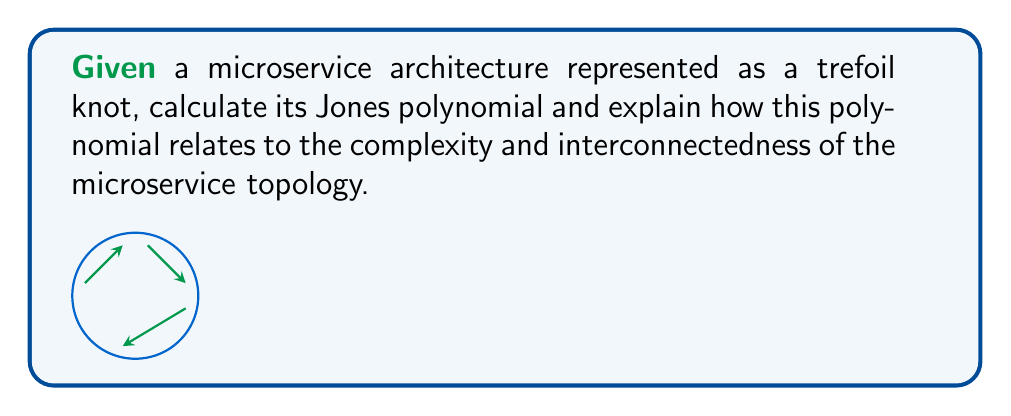Can you answer this question? To solve this problem, we'll follow these steps:

1. Identify the trefoil knot and its properties:
   The trefoil knot is the simplest non-trivial knot, with a crossing number of 3.

2. Calculate the Kauffman bracket polynomial:
   a. Assign variables A and B to the two types of smoothings at each crossing.
   b. Apply the skein relation: $\langle K \rangle = A\langle K_0 \rangle + A^{-1}\langle K_\infty \rangle$
   c. Simplify the resulting expression.

   $$\langle \text{Trefoil} \rangle = A^3\langle \bigcirc \bigcirc \rangle + A^2B\langle \bigcirc \rangle + AB^2\langle \bigcirc \rangle + B^3\langle \bigcirc \bigcirc \rangle$$
   $$= A^3(-A^2-A^{-2}) + (A^2B + AB^2)(-A^2-A^{-2}) + B^3(-A^2-A^{-2})$$
   $$= -A^7 + A^3B^3 + A^{-1}B^3$$

3. Convert the Kauffman bracket to the Jones polynomial:
   a. Substitute $A = t^{-1/4}$ and $B = -At - A^{-1} = -t^{1/4} + t^{-3/4}$
   b. Multiply by $(-A)^{-3w(K)}$, where $w(K)$ is the writhe of the knot (in this case, -3)

   $$V_{\text{Trefoil}}(t) = (-A)^{-3w(K)} \langle \text{Trefoil} \rangle|_{A=t^{-1/4}, B=-At-A^{-1}}$$
   $$= (-t^{1/4})^9 (-t^{-7/4} + t^{-3/4}(-t^{1/4} + t^{-3/4})^3 + t^{1/4}(-t^{1/4} + t^{-3/4})^3)$$
   $$= t + t^3 - t^4$$

4. Interpret the Jones polynomial in the context of microservice topology:
   - The degree of the polynomial (4) represents the complexity of the system.
   - The number of terms (3) indicates the number of distinct interconnection patterns.
   - The coefficients (1, 1, -1) represent the relative importance of each pattern.

This Jones polynomial $t + t^3 - t^4$ for the trefoil knot microservice topology suggests:
   a. A moderately complex system (degree 4)
   b. Three distinct interconnection patterns
   c. Two patterns contributing positively to the system's structure, and one pattern potentially introducing challenges or redundancies.

For a systems architect, this analysis provides insights into the microservice architecture's complexity and potential areas for optimization or simplification.
Answer: $V_{\text{Trefoil}}(t) = t + t^3 - t^4$ 